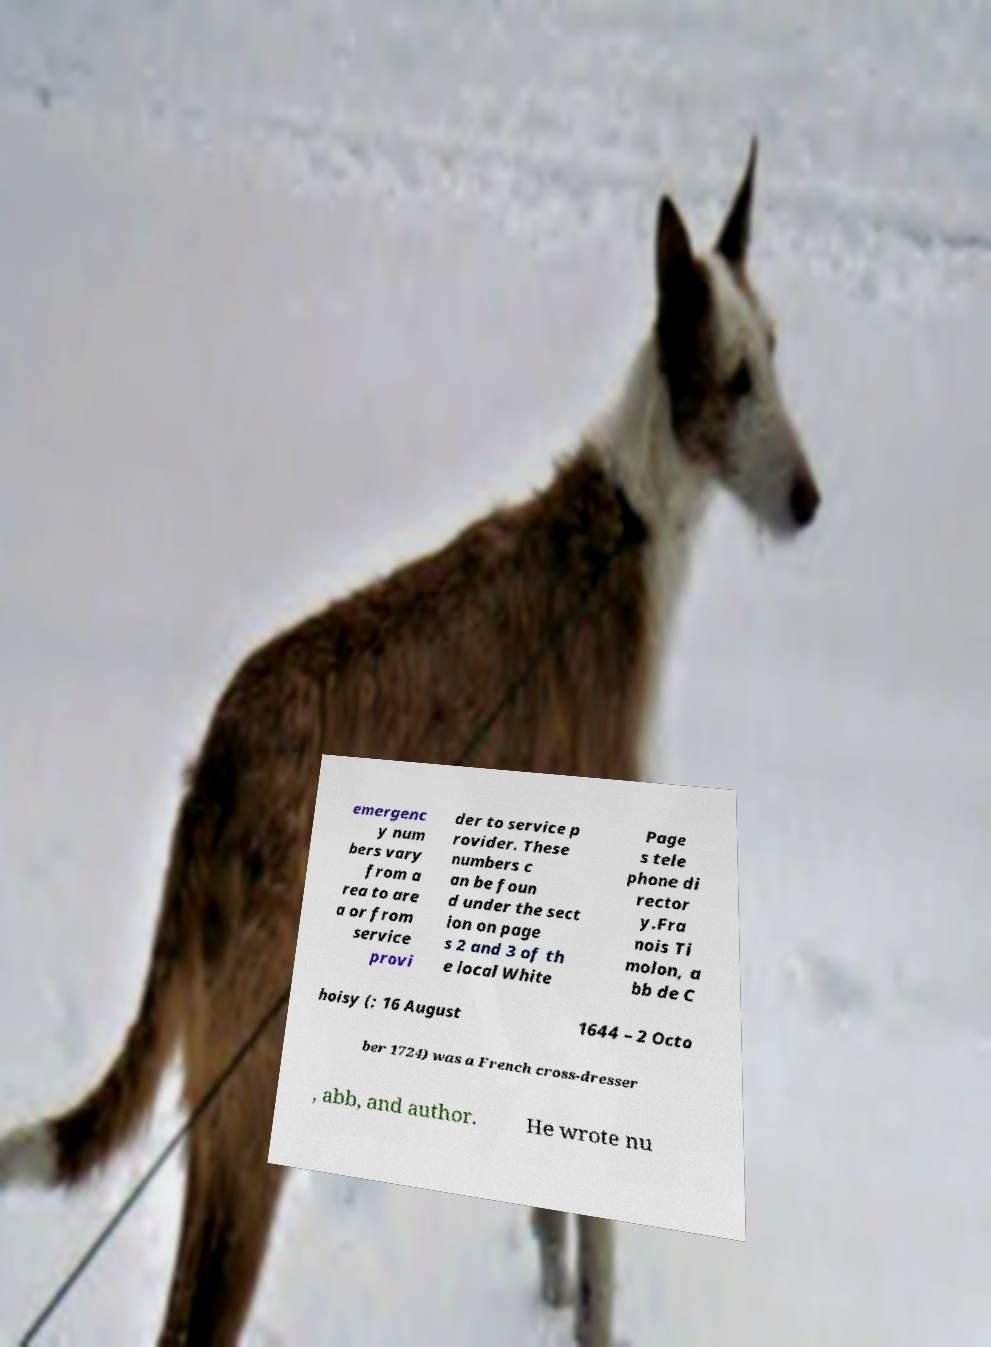Can you accurately transcribe the text from the provided image for me? emergenc y num bers vary from a rea to are a or from service provi der to service p rovider. These numbers c an be foun d under the sect ion on page s 2 and 3 of th e local White Page s tele phone di rector y.Fra nois Ti molon, a bb de C hoisy (; 16 August 1644 – 2 Octo ber 1724) was a French cross-dresser , abb, and author. He wrote nu 